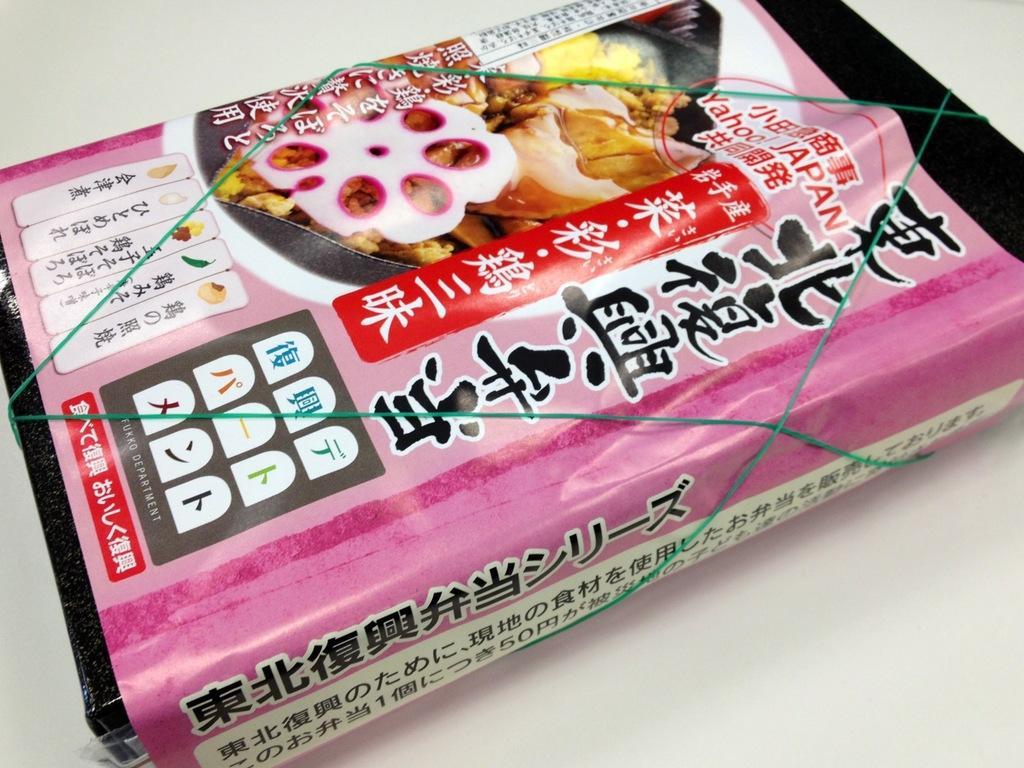In one or two sentences, can you explain what this image depicts? In the image there is some object wrapped with a paper and tied with a rubber band. 